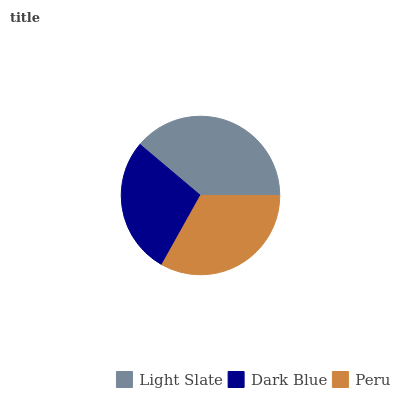Is Dark Blue the minimum?
Answer yes or no. Yes. Is Light Slate the maximum?
Answer yes or no. Yes. Is Peru the minimum?
Answer yes or no. No. Is Peru the maximum?
Answer yes or no. No. Is Peru greater than Dark Blue?
Answer yes or no. Yes. Is Dark Blue less than Peru?
Answer yes or no. Yes. Is Dark Blue greater than Peru?
Answer yes or no. No. Is Peru less than Dark Blue?
Answer yes or no. No. Is Peru the high median?
Answer yes or no. Yes. Is Peru the low median?
Answer yes or no. Yes. Is Light Slate the high median?
Answer yes or no. No. Is Light Slate the low median?
Answer yes or no. No. 